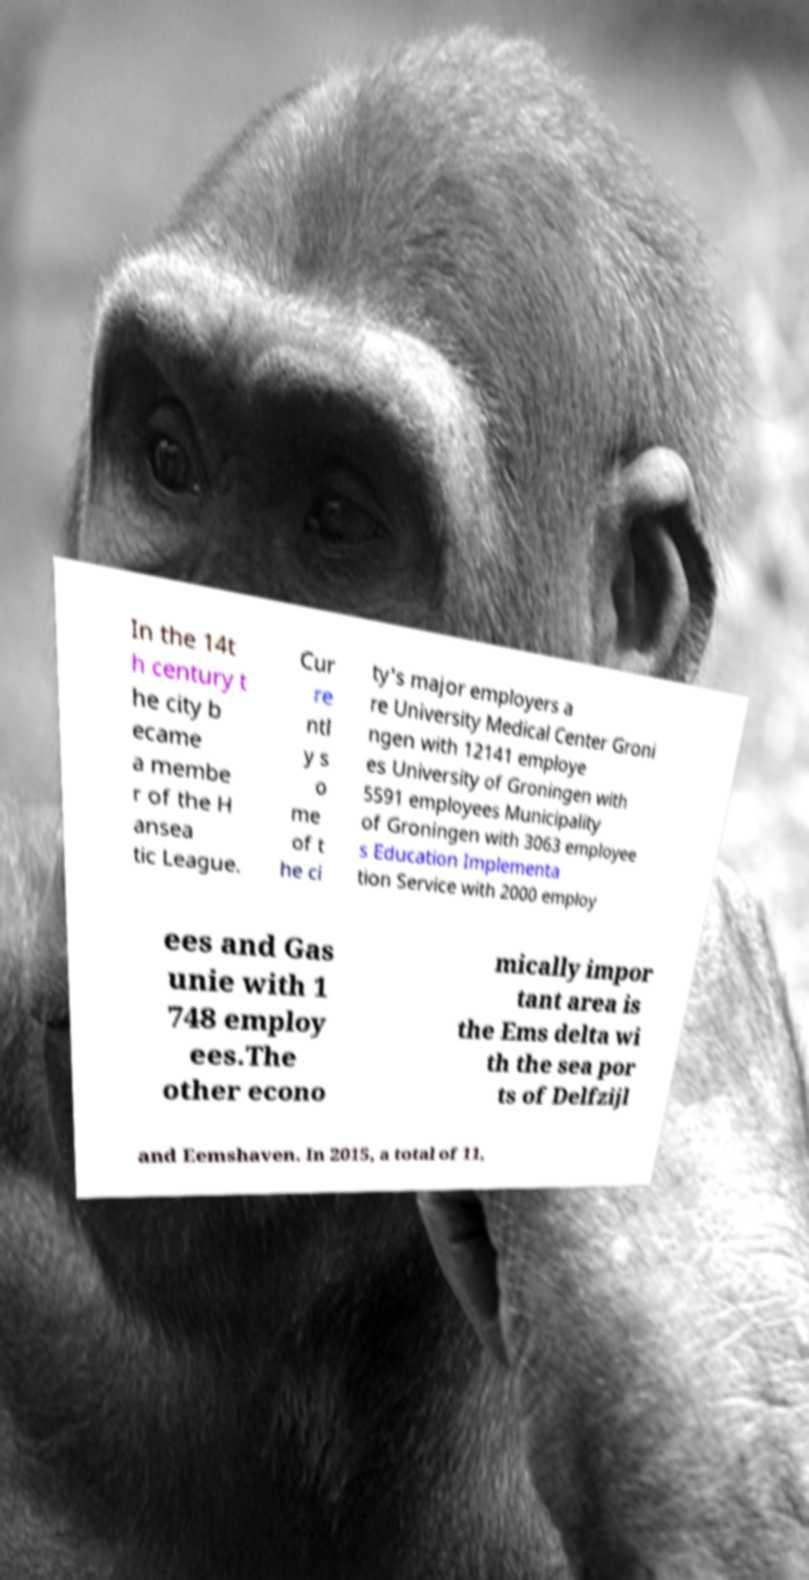What messages or text are displayed in this image? I need them in a readable, typed format. In the 14t h century t he city b ecame a membe r of the H ansea tic League. Cur re ntl y s o me of t he ci ty's major employers a re University Medical Center Groni ngen with 12141 employe es University of Groningen with 5591 employees Municipality of Groningen with 3063 employee s Education Implementa tion Service with 2000 employ ees and Gas unie with 1 748 employ ees.The other econo mically impor tant area is the Ems delta wi th the sea por ts of Delfzijl and Eemshaven. In 2015, a total of 11, 